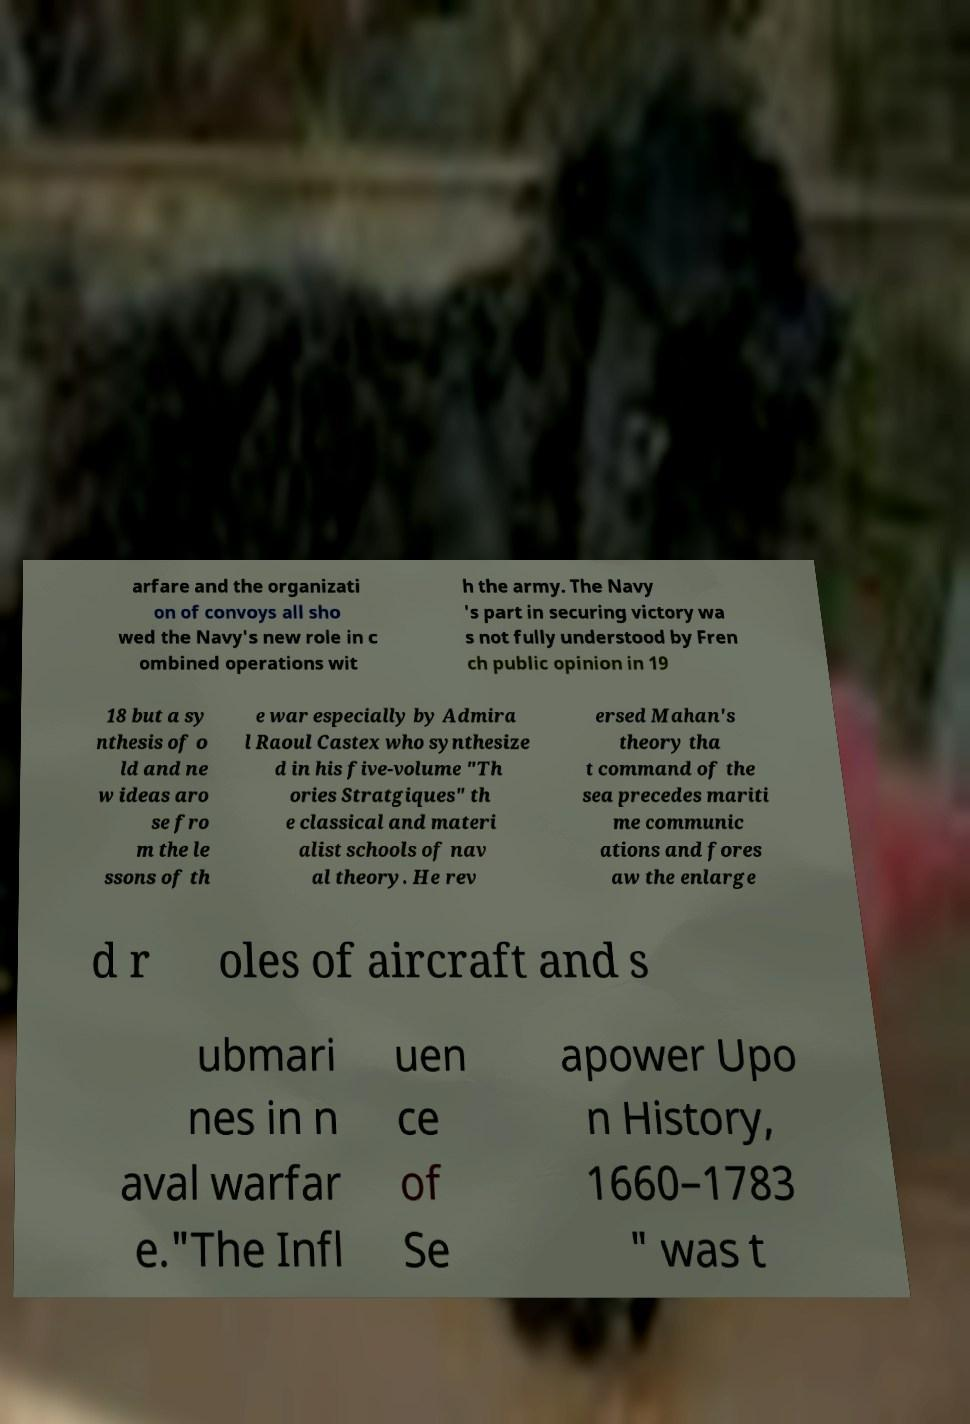Please identify and transcribe the text found in this image. arfare and the organizati on of convoys all sho wed the Navy's new role in c ombined operations wit h the army. The Navy 's part in securing victory wa s not fully understood by Fren ch public opinion in 19 18 but a sy nthesis of o ld and ne w ideas aro se fro m the le ssons of th e war especially by Admira l Raoul Castex who synthesize d in his five-volume "Th ories Stratgiques" th e classical and materi alist schools of nav al theory. He rev ersed Mahan's theory tha t command of the sea precedes mariti me communic ations and fores aw the enlarge d r oles of aircraft and s ubmari nes in n aval warfar e."The Infl uen ce of Se apower Upo n History, 1660–1783 " was t 